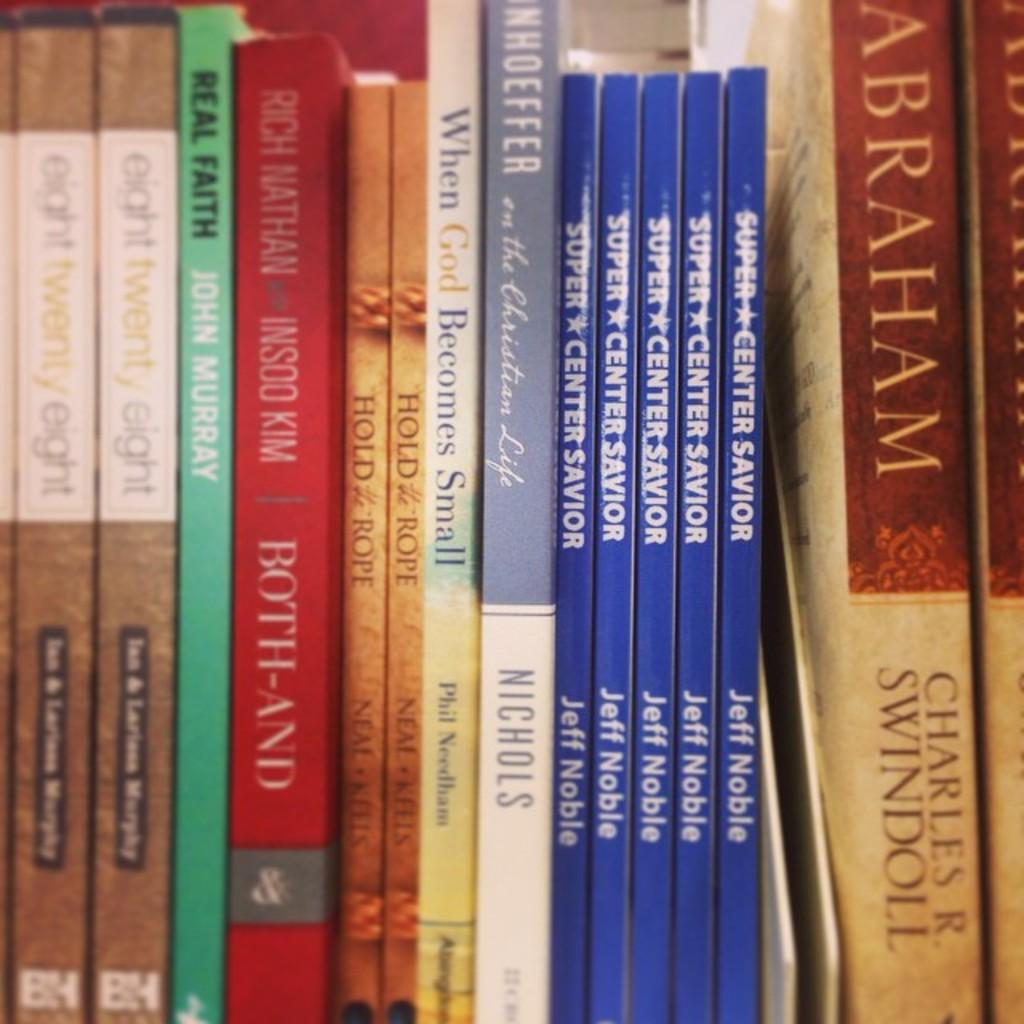Provide a one-sentence caption for the provided image. nine paperbook books on a shelf about religon. 